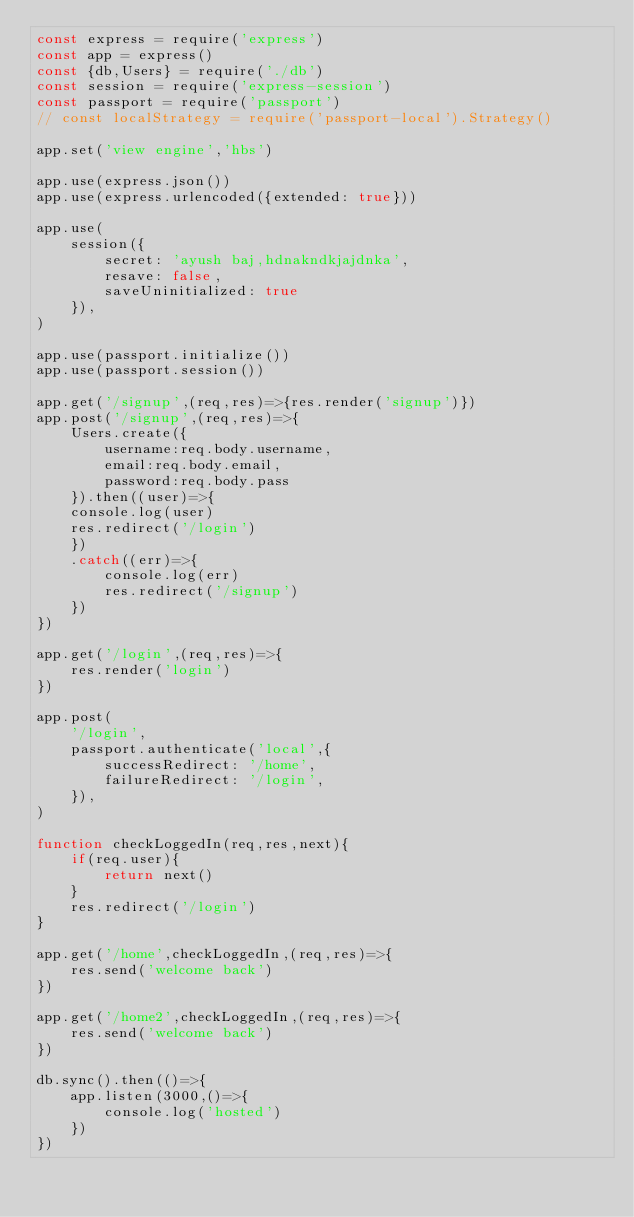Convert code to text. <code><loc_0><loc_0><loc_500><loc_500><_JavaScript_>const express = require('express')
const app = express()
const {db,Users} = require('./db')
const session = require('express-session')
const passport = require('passport')
// const localStrategy = require('passport-local').Strategy()

app.set('view engine','hbs')

app.use(express.json())
app.use(express.urlencoded({extended: true}))

app.use(
    session({
        secret: 'ayush baj,hdnakndkjajdnka',
        resave: false,
        saveUninitialized: true
    }),
)

app.use(passport.initialize())
app.use(passport.session())

app.get('/signup',(req,res)=>{res.render('signup')})
app.post('/signup',(req,res)=>{
    Users.create({
        username:req.body.username,
        email:req.body.email,
        password:req.body.pass
    }).then((user)=>{
    console.log(user)
    res.redirect('/login')
    })
    .catch((err)=>{
        console.log(err)
        res.redirect('/signup')
    })
})

app.get('/login',(req,res)=>{
    res.render('login')
})

app.post(
    '/login',
    passport.authenticate('local',{
        successRedirect: '/home',
        failureRedirect: '/login',
    }),
)

function checkLoggedIn(req,res,next){
    if(req.user){
        return next()
    }
    res.redirect('/login')
}

app.get('/home',checkLoggedIn,(req,res)=>{
    res.send('welcome back')
})

app.get('/home2',checkLoggedIn,(req,res)=>{
    res.send('welcome back')
})

db.sync().then(()=>{
    app.listen(3000,()=>{
        console.log('hosted')
    })
})</code> 